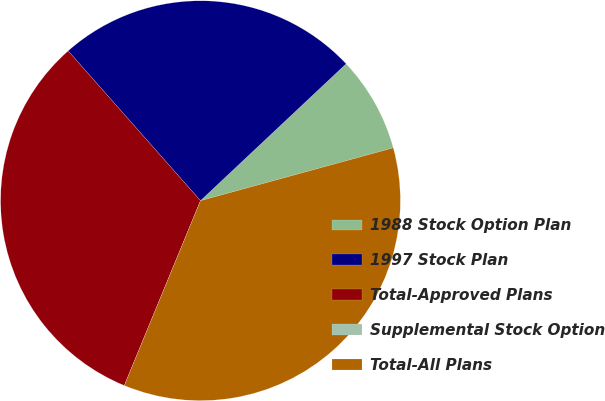Convert chart to OTSL. <chart><loc_0><loc_0><loc_500><loc_500><pie_chart><fcel>1988 Stock Option Plan<fcel>1997 Stock Plan<fcel>Total-Approved Plans<fcel>Supplemental Stock Option<fcel>Total-All Plans<nl><fcel>7.75%<fcel>24.51%<fcel>32.26%<fcel>0.0%<fcel>35.48%<nl></chart> 